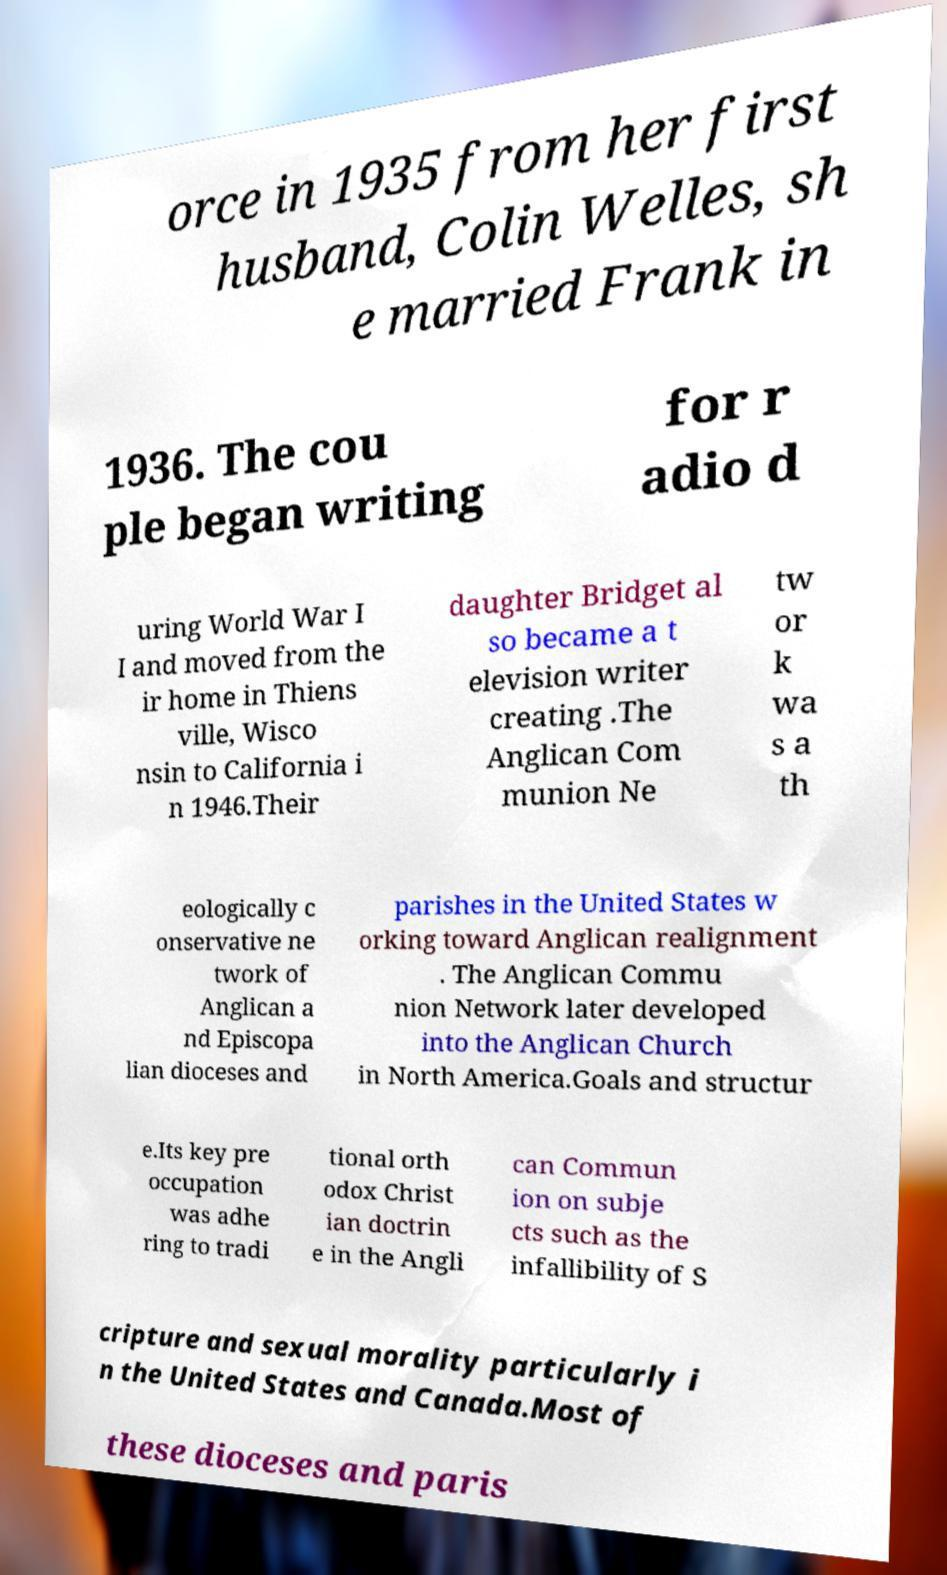Please read and relay the text visible in this image. What does it say? orce in 1935 from her first husband, Colin Welles, sh e married Frank in 1936. The cou ple began writing for r adio d uring World War I I and moved from the ir home in Thiens ville, Wisco nsin to California i n 1946.Their daughter Bridget al so became a t elevision writer creating .The Anglican Com munion Ne tw or k wa s a th eologically c onservative ne twork of Anglican a nd Episcopa lian dioceses and parishes in the United States w orking toward Anglican realignment . The Anglican Commu nion Network later developed into the Anglican Church in North America.Goals and structur e.Its key pre occupation was adhe ring to tradi tional orth odox Christ ian doctrin e in the Angli can Commun ion on subje cts such as the infallibility of S cripture and sexual morality particularly i n the United States and Canada.Most of these dioceses and paris 